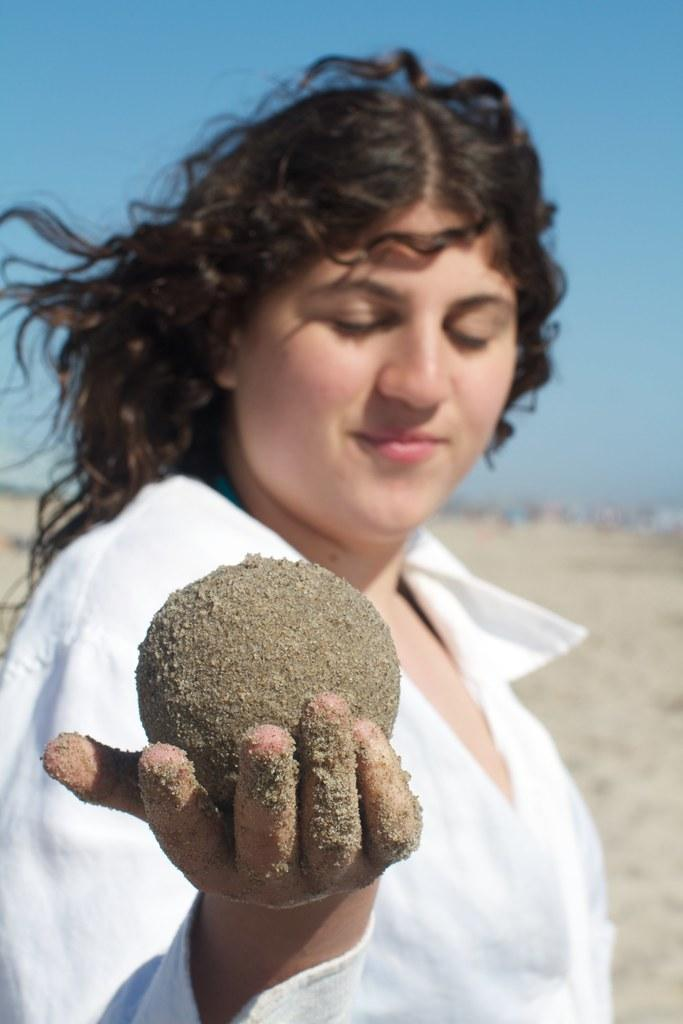Who is the main subject in the image? There is a woman in the image. What is the woman holding in her hand? The woman is holding a sand ball in her hand. What is the woman wearing in the image? The woman is wearing a white dress. What can be seen in the background of the image? There is sky visible in the background of the image. What type of pencil is the woman using to draw in the image? There is no pencil present in the image, and the woman is not drawing. 